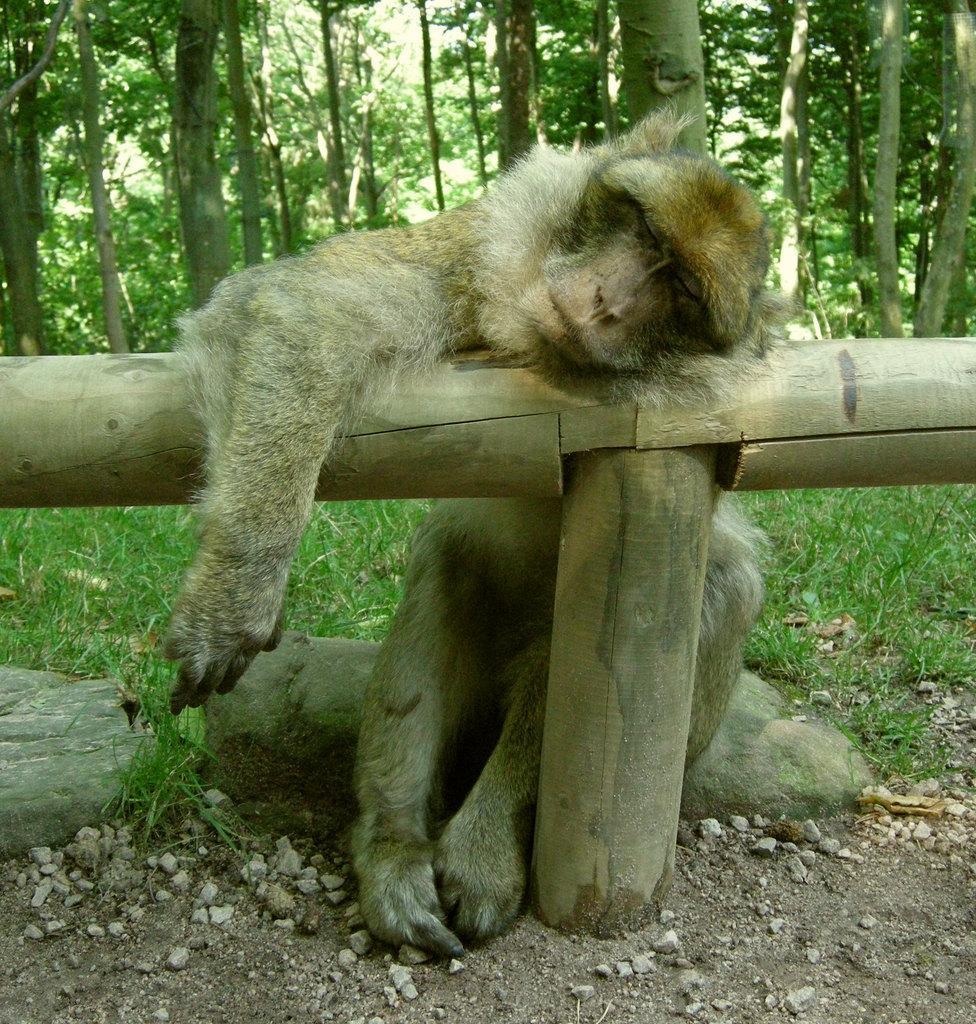Describe this image in one or two sentences. In this image there is a monkey sitting on the rock and resting her head on the wooden pole, behind her there are so many trees. 